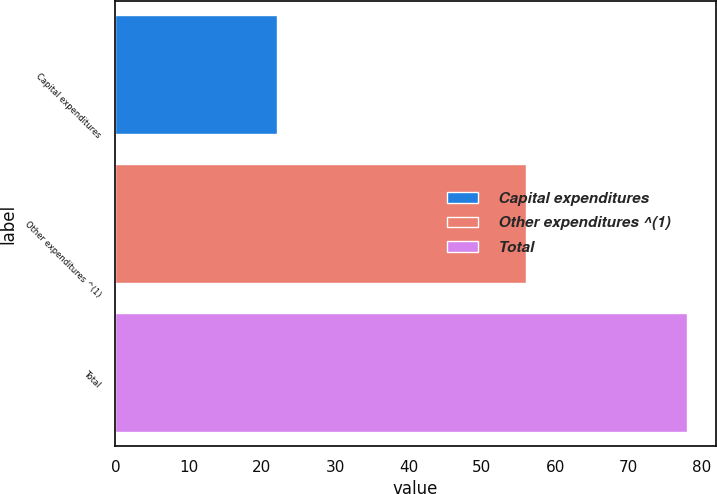<chart> <loc_0><loc_0><loc_500><loc_500><bar_chart><fcel>Capital expenditures<fcel>Other expenditures ^(1)<fcel>Total<nl><fcel>22<fcel>56<fcel>78<nl></chart> 